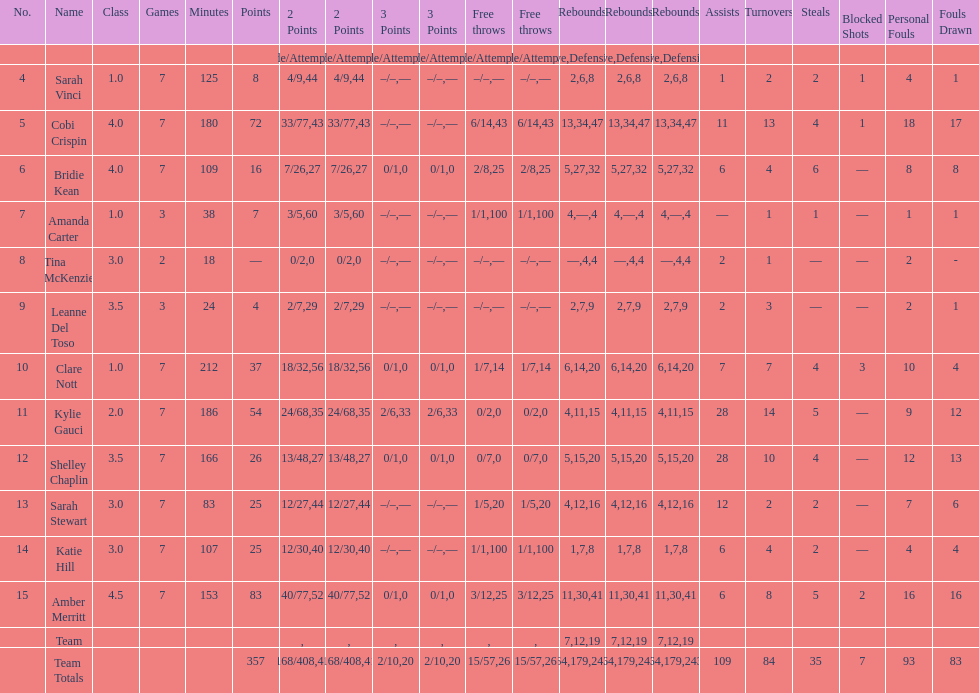What is the total count of both assists and turnovers? 193. 